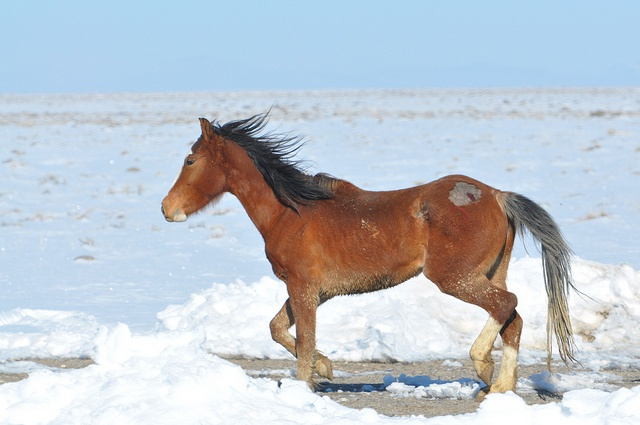Describe the objects in this image and their specific colors. I can see a horse in lightblue, brown, gray, and maroon tones in this image. 